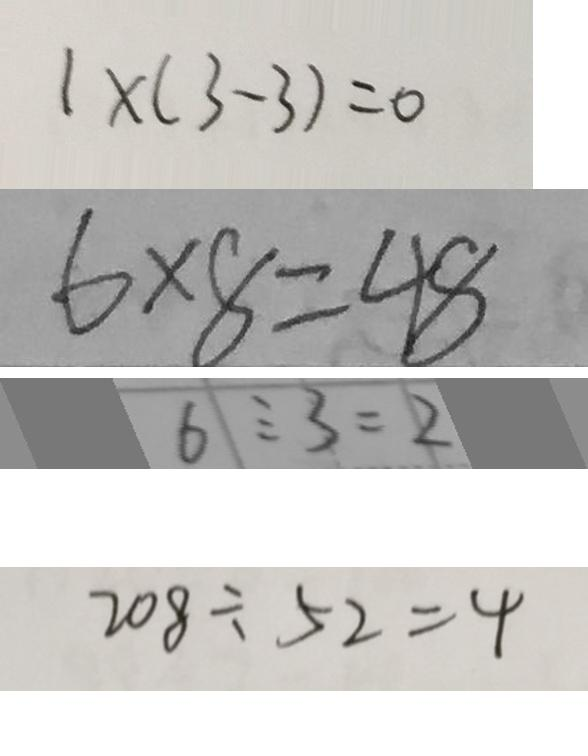<formula> <loc_0><loc_0><loc_500><loc_500>1 \times ( 3 - 3 ) = 0 
 6 \times 8 = 4 8 
 6 \div 3 = 2 
 2 0 8 \div 5 2 = 4</formula> 